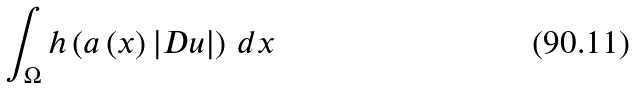<formula> <loc_0><loc_0><loc_500><loc_500>\int _ { \Omega } h \left ( a \left ( x \right ) \left | D u \right | \right ) \, d x</formula> 